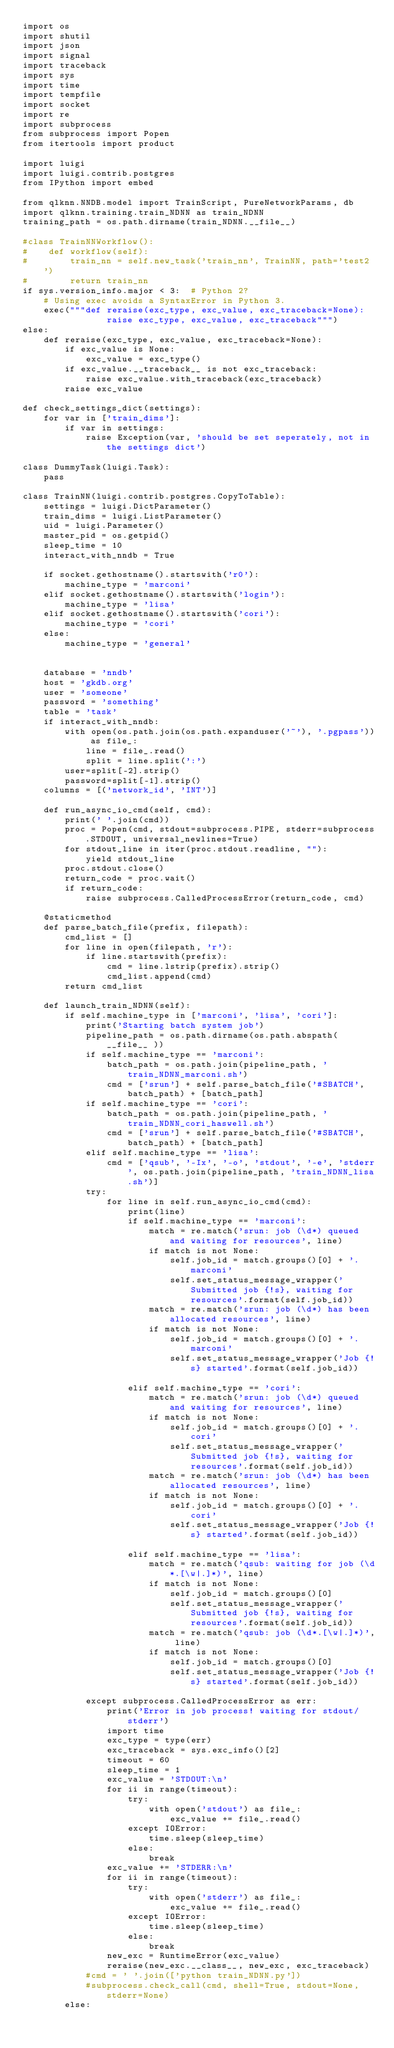<code> <loc_0><loc_0><loc_500><loc_500><_Python_>import os
import shutil
import json
import signal
import traceback
import sys
import time
import tempfile
import socket
import re
import subprocess
from subprocess import Popen
from itertools import product

import luigi
import luigi.contrib.postgres
from IPython import embed

from qlknn.NNDB.model import TrainScript, PureNetworkParams, db
import qlknn.training.train_NDNN as train_NDNN
training_path = os.path.dirname(train_NDNN.__file__)

#class TrainNNWorkflow():
#    def workflow(self):
#        train_nn = self.new_task('train_nn', TrainNN, path='test2')
#        return train_nn
if sys.version_info.major < 3:  # Python 2?
    # Using exec avoids a SyntaxError in Python 3.
    exec("""def reraise(exc_type, exc_value, exc_traceback=None):
                raise exc_type, exc_value, exc_traceback""")
else:
    def reraise(exc_type, exc_value, exc_traceback=None):
        if exc_value is None:
            exc_value = exc_type()
        if exc_value.__traceback__ is not exc_traceback:
            raise exc_value.with_traceback(exc_traceback)
        raise exc_value

def check_settings_dict(settings):
    for var in ['train_dims']:
        if var in settings:
            raise Exception(var, 'should be set seperately, not in the settings dict')

class DummyTask(luigi.Task):
    pass

class TrainNN(luigi.contrib.postgres.CopyToTable):
    settings = luigi.DictParameter()
    train_dims = luigi.ListParameter()
    uid = luigi.Parameter()
    master_pid = os.getpid()
    sleep_time = 10
    interact_with_nndb = True

    if socket.gethostname().startswith('r0'):
        machine_type = 'marconi'
    elif socket.gethostname().startswith('login'):
        machine_type = 'lisa'
    elif socket.gethostname().startswith('cori'):
        machine_type = 'cori'
    else:
        machine_type = 'general'


    database = 'nndb'
    host = 'gkdb.org'
    user = 'someone'
    password = 'something'
    table = 'task'
    if interact_with_nndb:
        with open(os.path.join(os.path.expanduser('~'), '.pgpass')) as file_:
            line = file_.read()
            split = line.split(':')
        user=split[-2].strip()
        password=split[-1].strip()
    columns = [('network_id', 'INT')]

    def run_async_io_cmd(self, cmd):
        print(' '.join(cmd))
        proc = Popen(cmd, stdout=subprocess.PIPE, stderr=subprocess.STDOUT, universal_newlines=True)
        for stdout_line in iter(proc.stdout.readline, ""):
            yield stdout_line
        proc.stdout.close()
        return_code = proc.wait()
        if return_code:
            raise subprocess.CalledProcessError(return_code, cmd)

    @staticmethod
    def parse_batch_file(prefix, filepath):
        cmd_list = []
        for line in open(filepath, 'r'):
            if line.startswith(prefix):
                cmd = line.lstrip(prefix).strip()
                cmd_list.append(cmd)
        return cmd_list

    def launch_train_NDNN(self):
        if self.machine_type in ['marconi', 'lisa', 'cori']:
            print('Starting batch system job')
            pipeline_path = os.path.dirname(os.path.abspath( __file__ ))
            if self.machine_type == 'marconi':
                batch_path = os.path.join(pipeline_path, 'train_NDNN_marconi.sh')
                cmd = ['srun'] + self.parse_batch_file('#SBATCH', batch_path) + [batch_path]
            if self.machine_type == 'cori':
                batch_path = os.path.join(pipeline_path, 'train_NDNN_cori_haswell.sh')
                cmd = ['srun'] + self.parse_batch_file('#SBATCH', batch_path) + [batch_path]
            elif self.machine_type == 'lisa':
                cmd = ['qsub', '-Ix', '-o', 'stdout', '-e', 'stderr', os.path.join(pipeline_path, 'train_NDNN_lisa.sh')]
            try:
                for line in self.run_async_io_cmd(cmd):
                    print(line)
                    if self.machine_type == 'marconi':
                        match = re.match('srun: job (\d*) queued and waiting for resources', line)
                        if match is not None:
                            self.job_id = match.groups()[0] + '.marconi'
                            self.set_status_message_wrapper('Submitted job {!s}, waiting for resources'.format(self.job_id))
                        match = re.match('srun: job (\d*) has been allocated resources', line)
                        if match is not None:
                            self.job_id = match.groups()[0] + '.marconi'
                            self.set_status_message_wrapper('Job {!s} started'.format(self.job_id))

                    elif self.machine_type == 'cori':
                        match = re.match('srun: job (\d*) queued and waiting for resources', line)
                        if match is not None:
                            self.job_id = match.groups()[0] + '.cori'
                            self.set_status_message_wrapper('Submitted job {!s}, waiting for resources'.format(self.job_id))
                        match = re.match('srun: job (\d*) has been allocated resources', line)
                        if match is not None:
                            self.job_id = match.groups()[0] + '.cori'
                            self.set_status_message_wrapper('Job {!s} started'.format(self.job_id))

                    elif self.machine_type == 'lisa':
                        match = re.match('qsub: waiting for job (\d*.[\w|.]*)', line)
                        if match is not None:
                            self.job_id = match.groups()[0]
                            self.set_status_message_wrapper('Submitted job {!s}, waiting for resources'.format(self.job_id))
                        match = re.match('qsub: job (\d*.[\w|.]*)', line)
                        if match is not None:
                            self.job_id = match.groups()[0]
                            self.set_status_message_wrapper('Job {!s} started'.format(self.job_id))

            except subprocess.CalledProcessError as err:
                print('Error in job process! waiting for stdout/stderr')
                import time
                exc_type = type(err)
                exc_traceback = sys.exc_info()[2]
                timeout = 60
                sleep_time = 1
                exc_value = 'STDOUT:\n'
                for ii in range(timeout):
                    try:
                        with open('stdout') as file_:
                            exc_value += file_.read()
                    except IOError:
                        time.sleep(sleep_time)
                    else:
                        break
                exc_value += 'STDERR:\n'
                for ii in range(timeout):
                    try:
                        with open('stderr') as file_:
                            exc_value += file_.read()
                    except IOError:
                        time.sleep(sleep_time)
                    else:
                        break
                new_exc = RuntimeError(exc_value)
                reraise(new_exc.__class__, new_exc, exc_traceback)
            #cmd = ' '.join(['python train_NDNN.py'])
            #subprocess.check_call(cmd, shell=True, stdout=None, stderr=None)
        else:</code> 